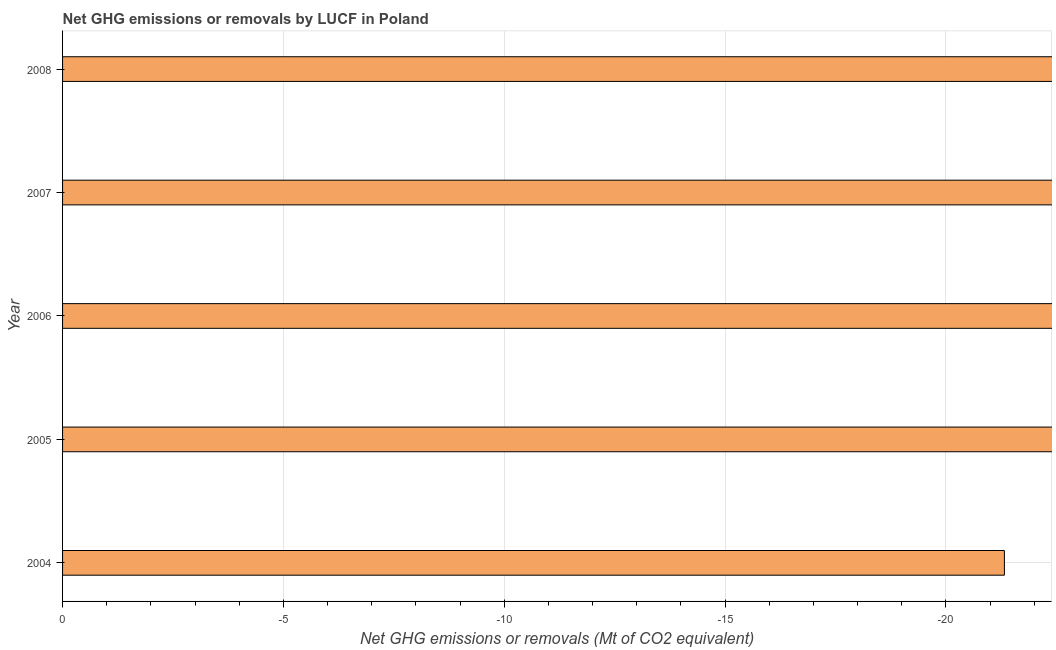Does the graph contain any zero values?
Keep it short and to the point. Yes. Does the graph contain grids?
Your response must be concise. Yes. What is the title of the graph?
Offer a very short reply. Net GHG emissions or removals by LUCF in Poland. What is the label or title of the X-axis?
Your answer should be very brief. Net GHG emissions or removals (Mt of CO2 equivalent). What is the label or title of the Y-axis?
Your response must be concise. Year. Across all years, what is the minimum ghg net emissions or removals?
Provide a short and direct response. 0. What is the sum of the ghg net emissions or removals?
Provide a succinct answer. 0. What is the average ghg net emissions or removals per year?
Offer a very short reply. 0. In how many years, is the ghg net emissions or removals greater than -19 Mt?
Provide a short and direct response. 0. In how many years, is the ghg net emissions or removals greater than the average ghg net emissions or removals taken over all years?
Make the answer very short. 0. Are all the bars in the graph horizontal?
Give a very brief answer. Yes. What is the difference between two consecutive major ticks on the X-axis?
Make the answer very short. 5. What is the Net GHG emissions or removals (Mt of CO2 equivalent) in 2007?
Make the answer very short. 0. 